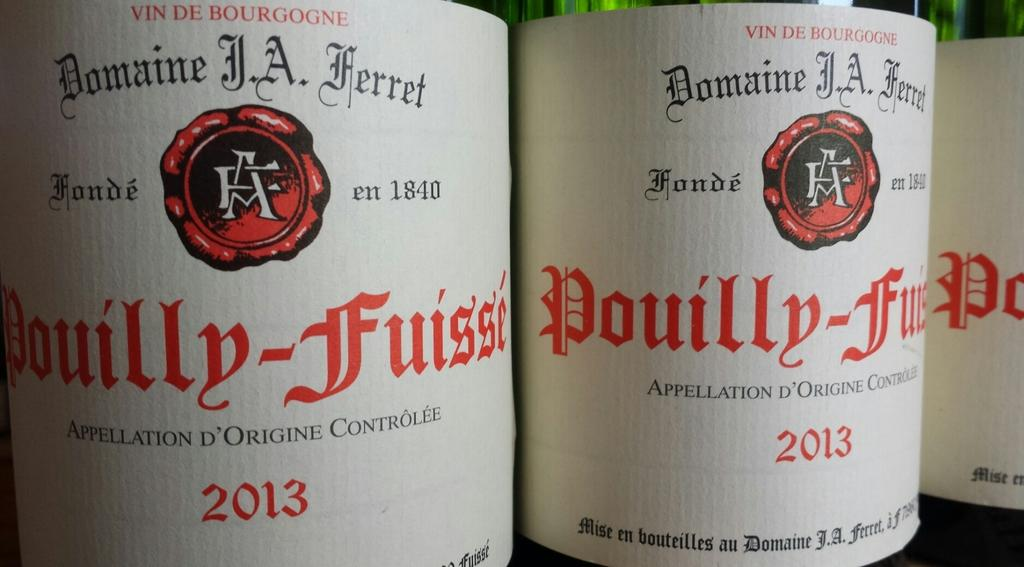<image>
Present a compact description of the photo's key features. Bottles of Pouillu-fussi from 2013 are lined up next to each other. 